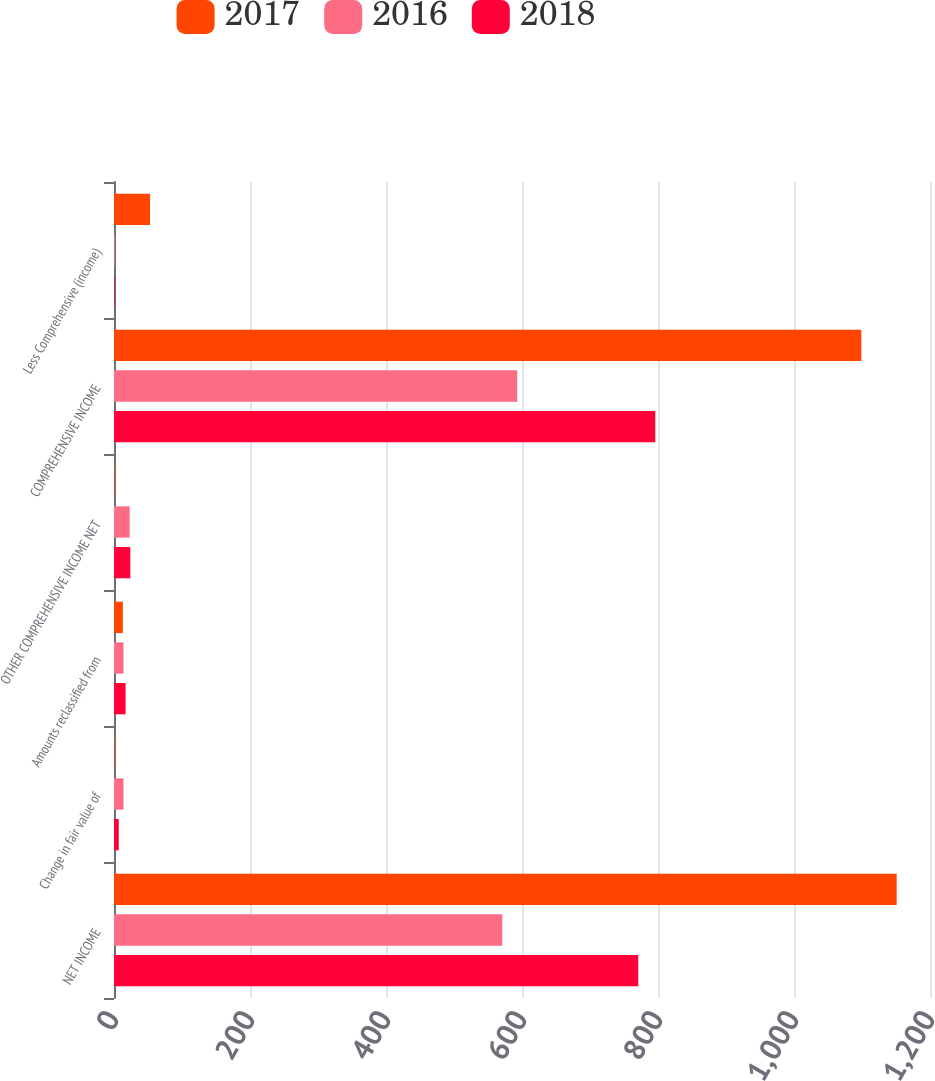Convert chart. <chart><loc_0><loc_0><loc_500><loc_500><stacked_bar_chart><ecel><fcel>NET INCOME<fcel>Change in fair value of<fcel>Amounts reclassified from<fcel>OTHER COMPREHENSIVE INCOME NET<fcel>COMPREHENSIVE INCOME<fcel>Less Comprehensive (income)<nl><fcel>2017<fcel>1151<fcel>1<fcel>13<fcel>1<fcel>1099<fcel>53<nl><fcel>2016<fcel>571<fcel>14<fcel>14<fcel>23<fcel>593<fcel>1<nl><fcel>2018<fcel>771<fcel>7<fcel>17<fcel>24<fcel>796<fcel>1<nl></chart> 